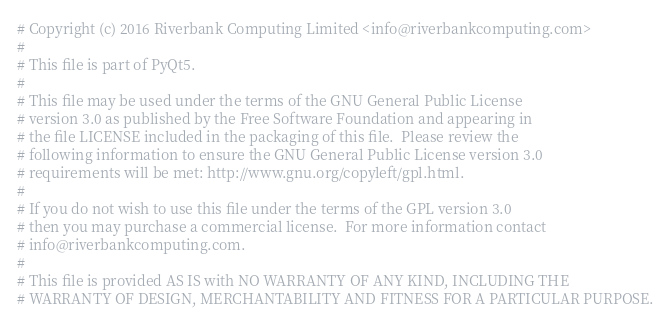<code> <loc_0><loc_0><loc_500><loc_500><_Python_># Copyright (c) 2016 Riverbank Computing Limited <info@riverbankcomputing.com>
# 
# This file is part of PyQt5.
# 
# This file may be used under the terms of the GNU General Public License
# version 3.0 as published by the Free Software Foundation and appearing in
# the file LICENSE included in the packaging of this file.  Please review the
# following information to ensure the GNU General Public License version 3.0
# requirements will be met: http://www.gnu.org/copyleft/gpl.html.
# 
# If you do not wish to use this file under the terms of the GPL version 3.0
# then you may purchase a commercial license.  For more information contact
# info@riverbankcomputing.com.
# 
# This file is provided AS IS with NO WARRANTY OF ANY KIND, INCLUDING THE
# WARRANTY OF DESIGN, MERCHANTABILITY AND FITNESS FOR A PARTICULAR PURPOSE.
</code> 